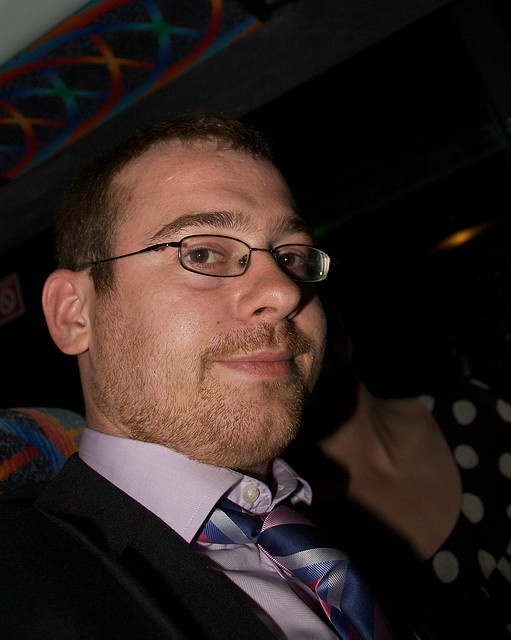Describe the objects in this image and their specific colors. I can see people in gray, black, brown, darkgray, and maroon tones, people in gray, black, maroon, and brown tones, and tie in gray, black, navy, and darkgray tones in this image. 